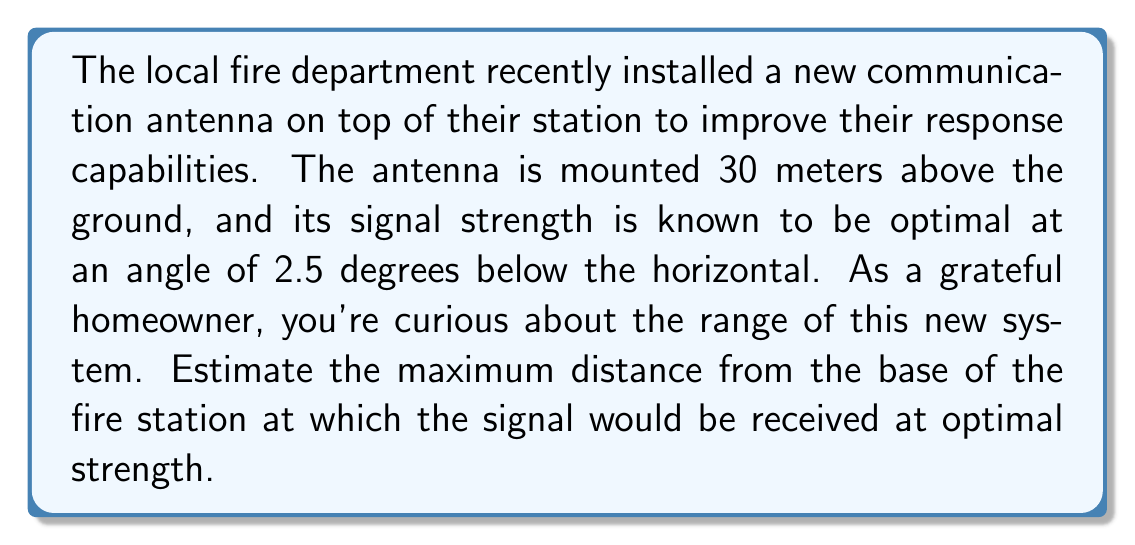Give your solution to this math problem. To solve this problem, we can use trigonometry, specifically the tangent function. Let's break it down step-by-step:

1) First, let's visualize the scenario:

[asy]
import geometry;

size(200);
pair A = (0,0), B = (0,3), C = (10,0);
draw(A--B--C--A);
label("30 m", B, W);
label("Ground", A--C, S);
label("Signal", B--C, NE);
label("2.5°", B, SE);
label("x", (5,0), S);
[/asy]

2) We're looking for the distance x, which forms the base of a right triangle. The height of this triangle is 30 meters (the antenna's height), and the angle between the signal and the horizontal is 2.5°.

3) In a right triangle, the tangent of an angle is the ratio of the opposite side to the adjacent side. In this case:

   $$\tan(2.5°) = \frac{\text{opposite}}{\text{adjacent}} = \frac{30}{x}$$

4) To find x, we need to solve this equation:

   $$x = \frac{30}{\tan(2.5°)}$$

5) Using a calculator (or a computer's trigonometric functions):

   $$x = \frac{30}{\tan(2.5°)} \approx 686.5 \text{ meters}$$

6) Therefore, the maximum distance from the base of the fire station at which the signal would be received at optimal strength is approximately 686.5 meters.
Answer: The maximum distance is approximately 686.5 meters. 